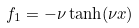Convert formula to latex. <formula><loc_0><loc_0><loc_500><loc_500>f _ { 1 } = - \nu \tanh ( \nu x )</formula> 